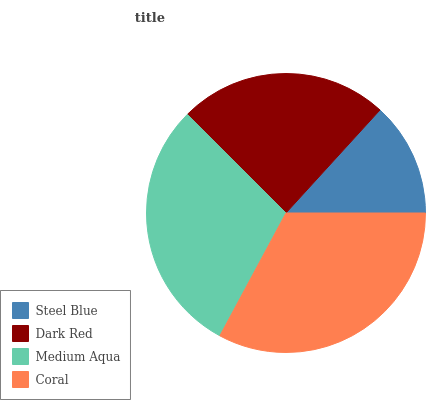Is Steel Blue the minimum?
Answer yes or no. Yes. Is Coral the maximum?
Answer yes or no. Yes. Is Dark Red the minimum?
Answer yes or no. No. Is Dark Red the maximum?
Answer yes or no. No. Is Dark Red greater than Steel Blue?
Answer yes or no. Yes. Is Steel Blue less than Dark Red?
Answer yes or no. Yes. Is Steel Blue greater than Dark Red?
Answer yes or no. No. Is Dark Red less than Steel Blue?
Answer yes or no. No. Is Medium Aqua the high median?
Answer yes or no. Yes. Is Dark Red the low median?
Answer yes or no. Yes. Is Steel Blue the high median?
Answer yes or no. No. Is Steel Blue the low median?
Answer yes or no. No. 